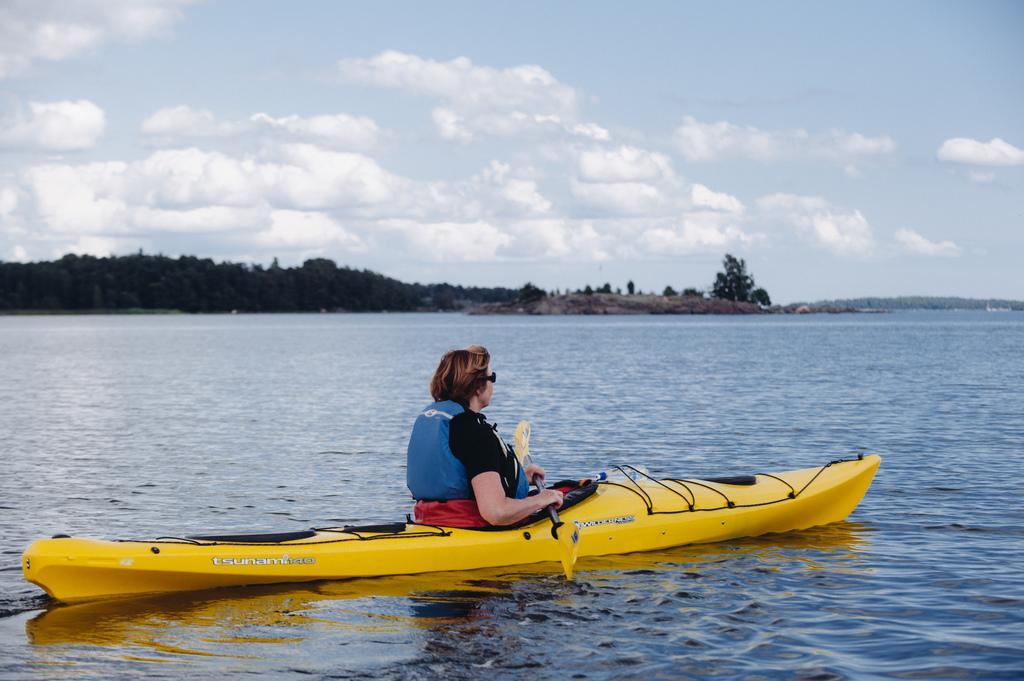Can you describe this image briefly? In this image, I can see a woman holding a paddle and sitting on a boat, which is on the water. In the background, there are trees and the sky. 